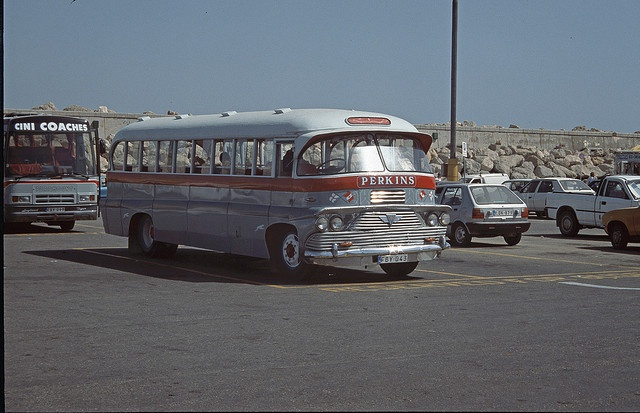Describe the objects in this image and their specific colors. I can see bus in black, gray, darkgray, and maroon tones, bus in black, gray, darkgray, and maroon tones, car in black, gray, darkgray, and lightgray tones, truck in black, gray, and darkgray tones, and car in black, gray, and lightgray tones in this image. 